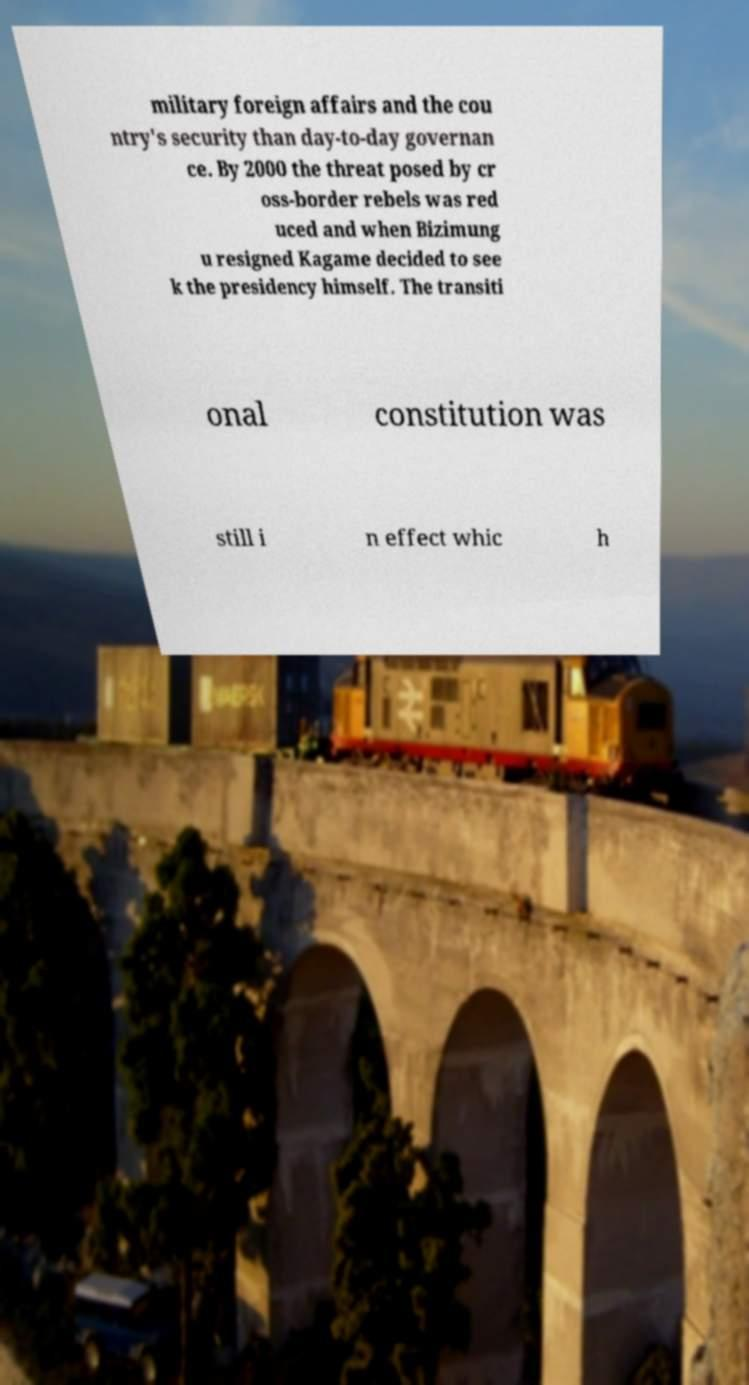Please read and relay the text visible in this image. What does it say? military foreign affairs and the cou ntry's security than day-to-day governan ce. By 2000 the threat posed by cr oss-border rebels was red uced and when Bizimung u resigned Kagame decided to see k the presidency himself. The transiti onal constitution was still i n effect whic h 